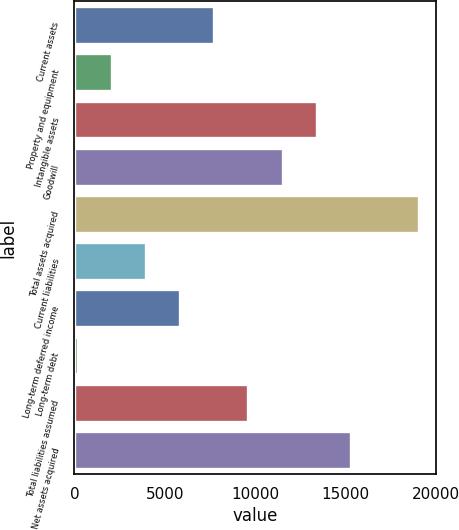Convert chart. <chart><loc_0><loc_0><loc_500><loc_500><bar_chart><fcel>Current assets<fcel>Property and equipment<fcel>Intangible assets<fcel>Goodwill<fcel>Total assets acquired<fcel>Current liabilities<fcel>Long-term deferred income<fcel>Long-term debt<fcel>Total liabilities assumed<fcel>Net assets acquired<nl><fcel>7735.6<fcel>2073.4<fcel>13397.8<fcel>11510.4<fcel>19060<fcel>3960.8<fcel>5848.2<fcel>186<fcel>9623<fcel>15285.2<nl></chart> 